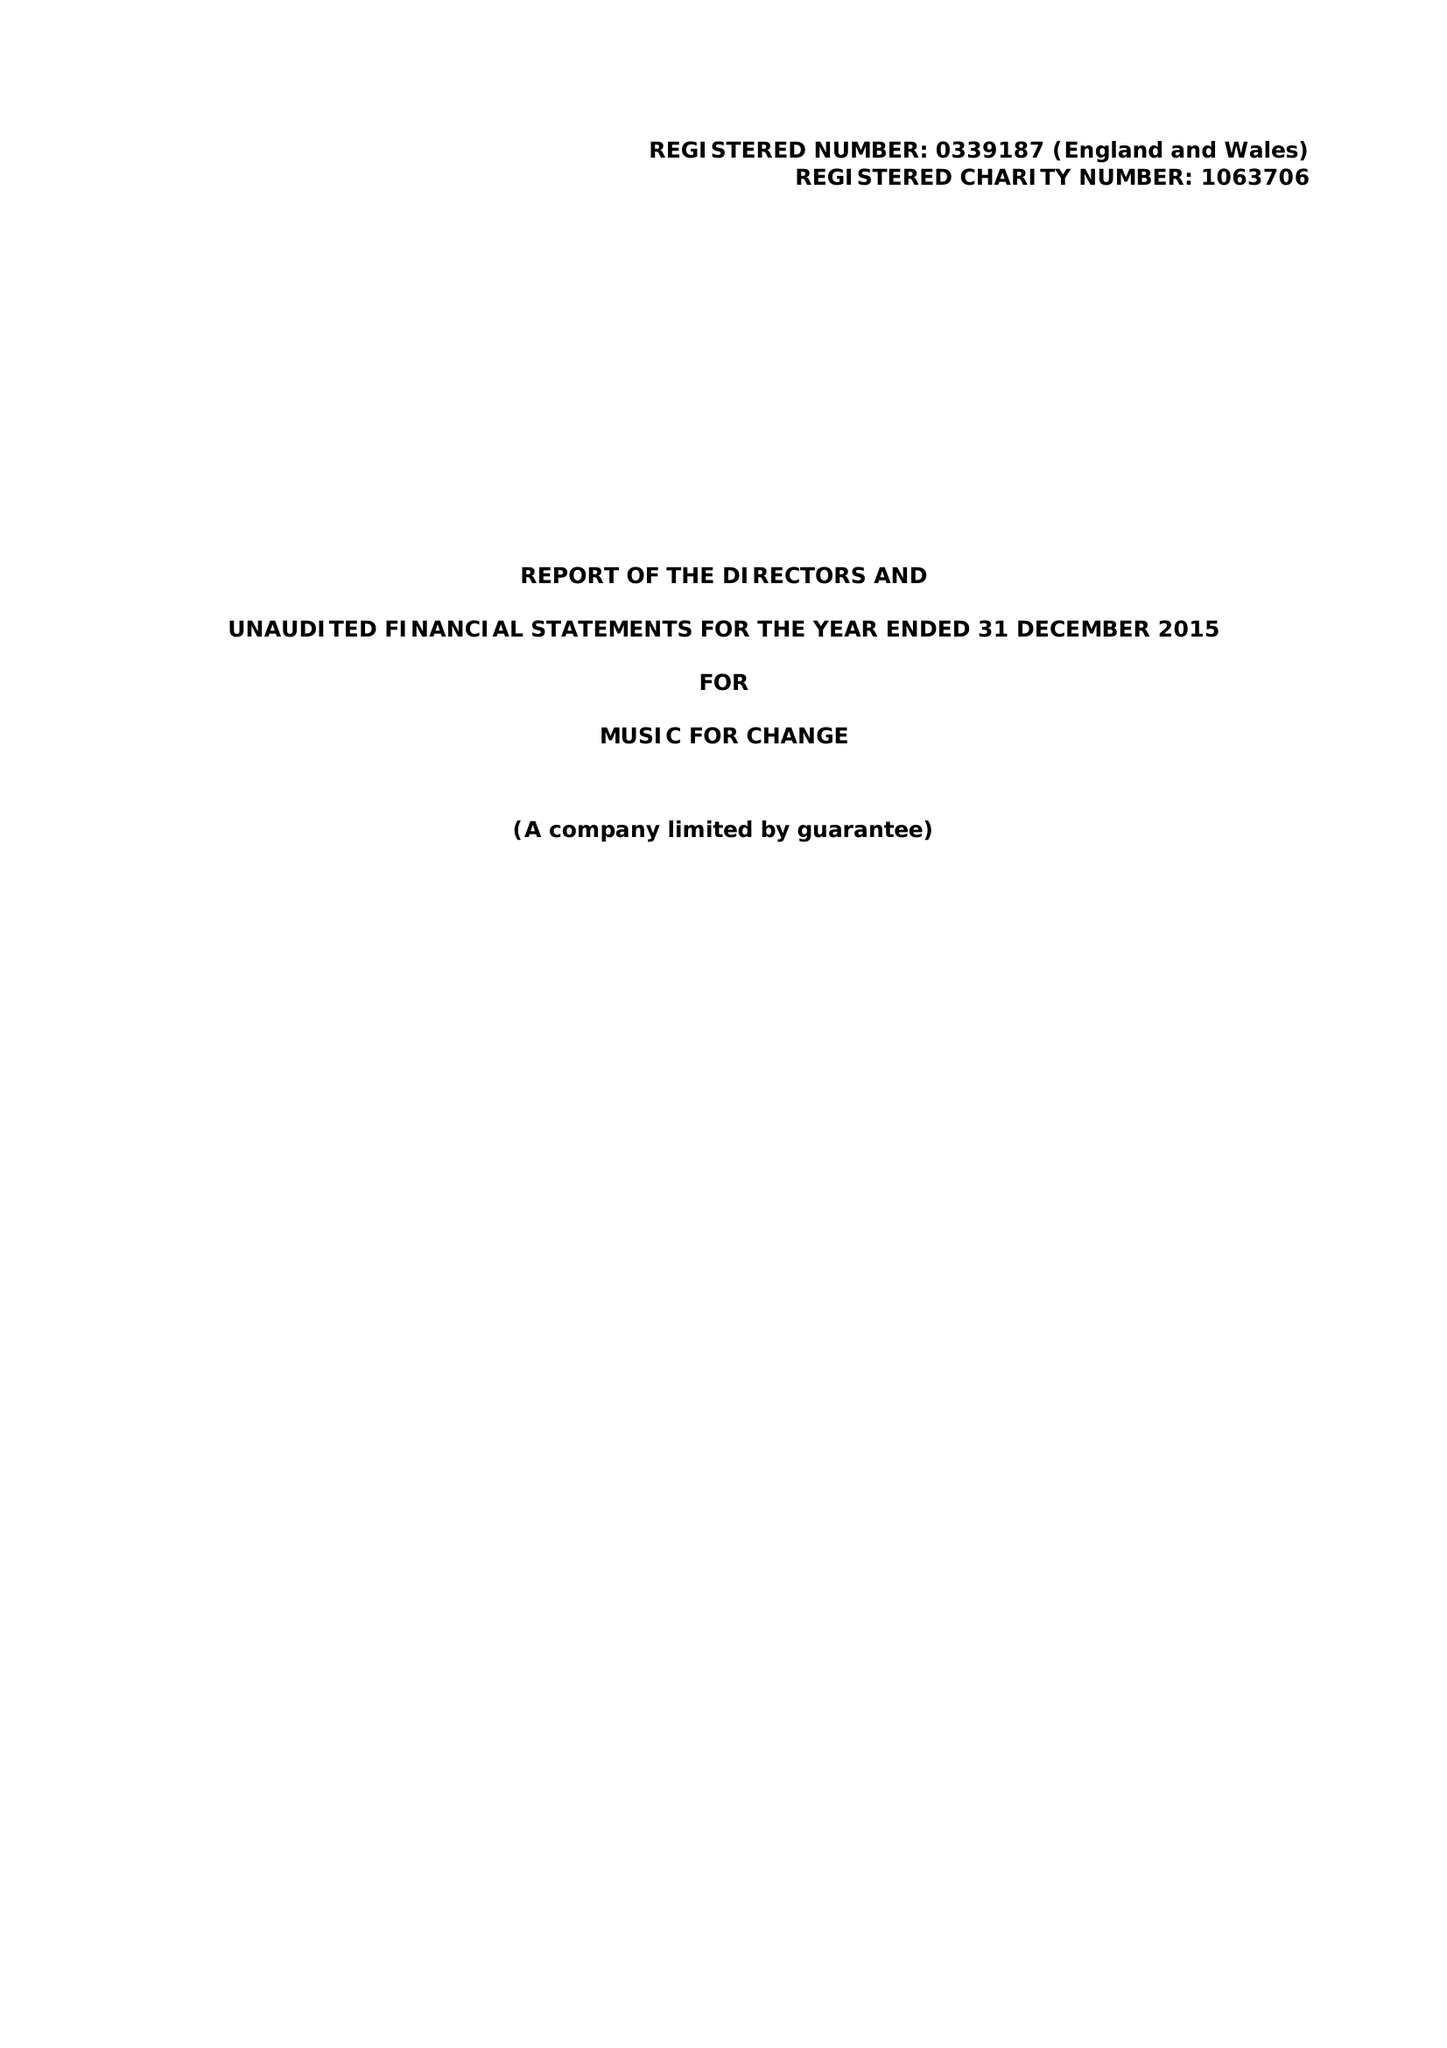What is the value for the charity_name?
Answer the question using a single word or phrase. Music For Change 